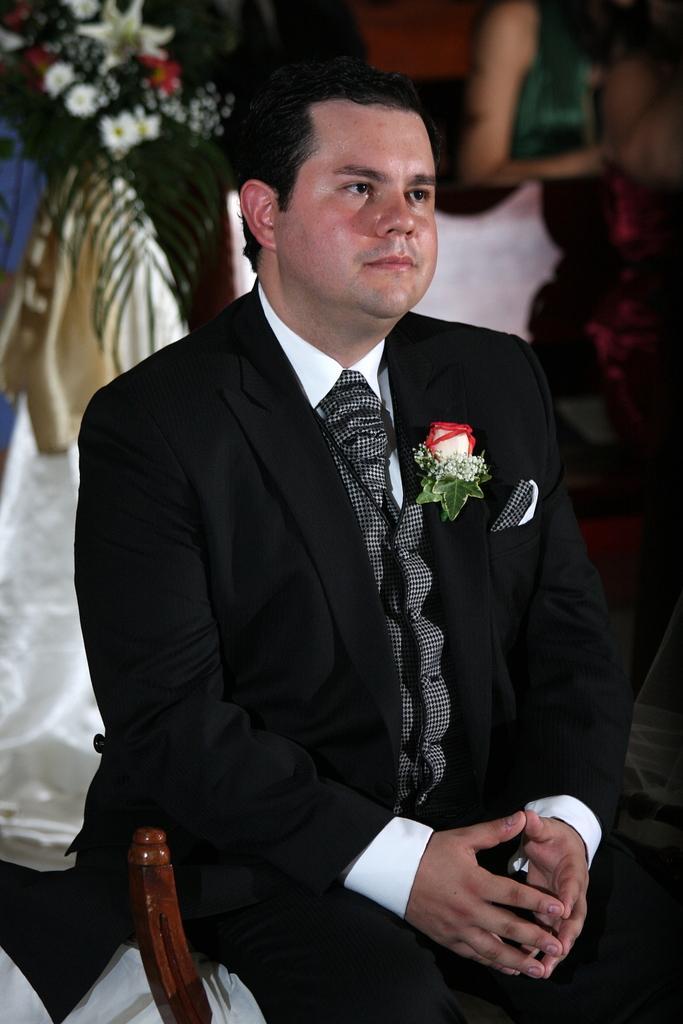Could you give a brief overview of what you see in this image? In this image, we can see a person wearing clothes. There are some flowers in the top left of the image. There is an another person in the top right of the image. 